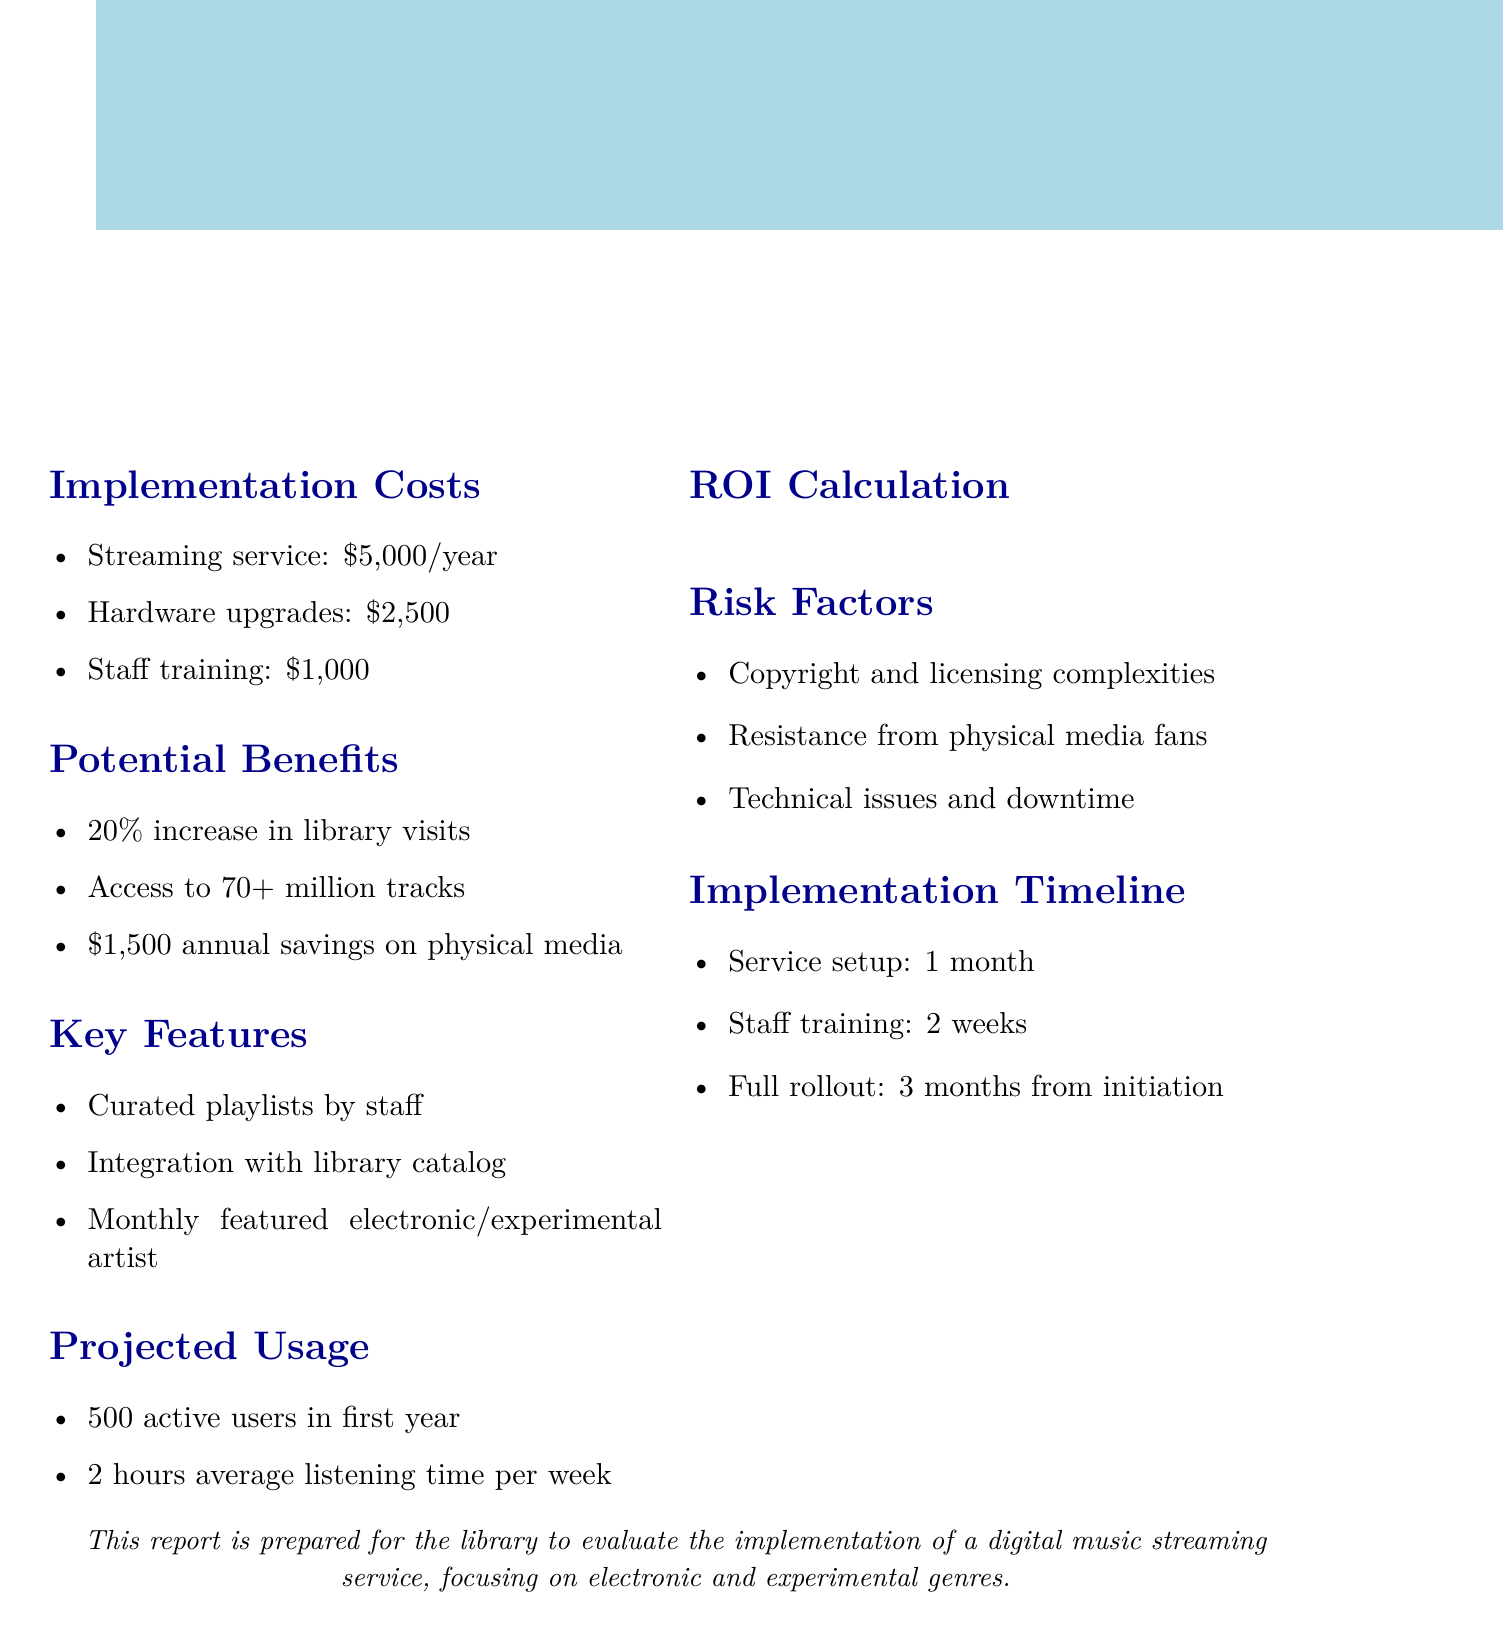what is the total annual cost? The total annual cost includes the subscription, hardware upgrades, and staff training, which adds up to $8,500.
Answer: $8,500 how many patrons are estimated to actively use the service in the first year? The document states that there will be 500 active users in the first year.
Answer: 500 patrons what percentage of increase in library visits is estimated? The report mentions an estimated 20% increase in library visits due to the service.
Answer: 20% how much will the library save annually on physical media? The document indicates savings of $1,500 annually on CD and vinyl purchases.
Answer: $1,500 what is the ROI percentage from implementing the streaming service? The ROI calculation shows a return on investment percentage of 41%.
Answer: 41% what feature is included for showcasing artists? The document lists a monthly featured artist from electronic/experimental genres as one of the key features.
Answer: Monthly featured artist what is the time frame for full rollout of the service? The implementation timeline states that the full rollout will occur 3 months from project initiation.
Answer: 3 months what is one of the risk factors mentioned in the report? The report lists copyright and licensing complexities as one of the risk factors.
Answer: Copyright and licensing complexities what is included in the hardware upgrades cost? The hardware upgrades cost refers to expenses for new audio equipment and headphones totaling $2,500.
Answer: New audio equipment and headphones 